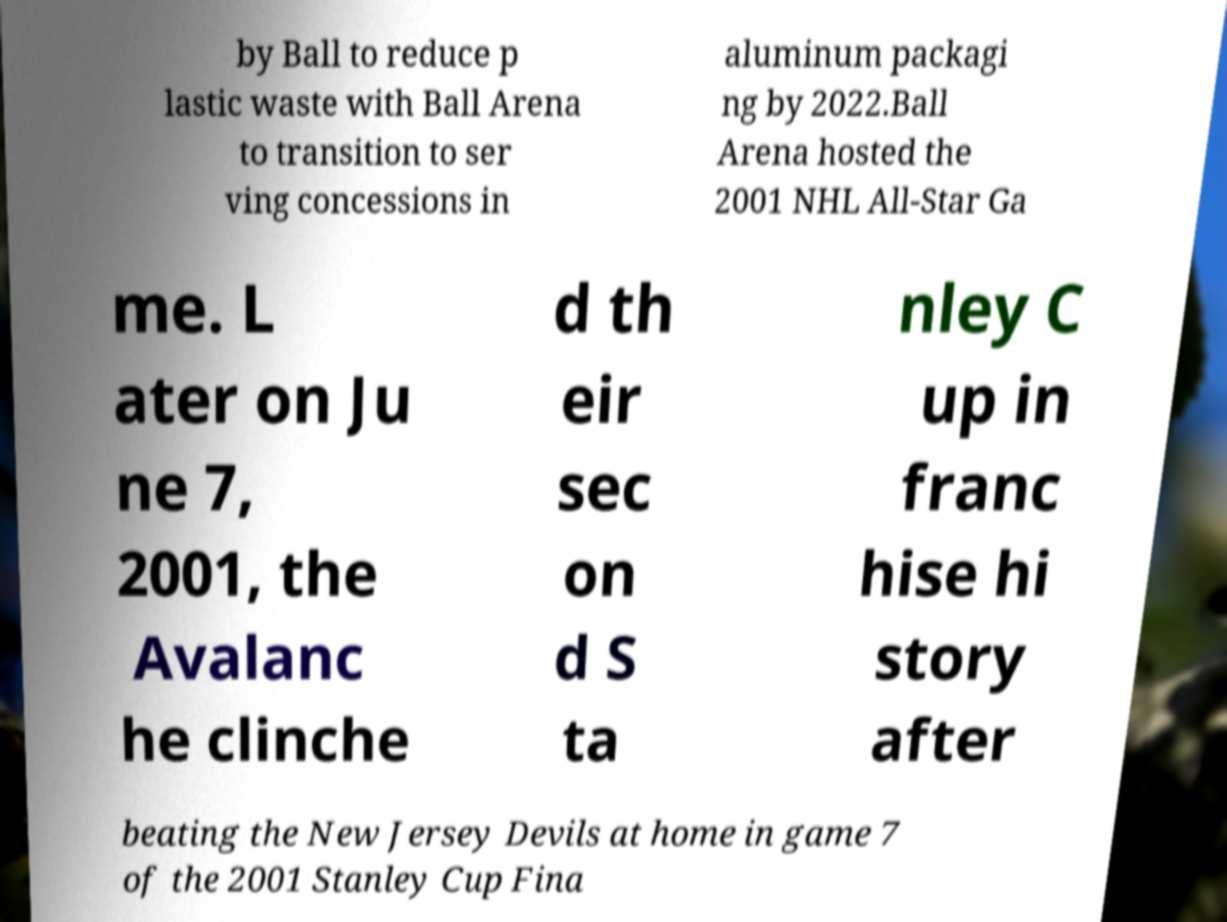Please read and relay the text visible in this image. What does it say? by Ball to reduce p lastic waste with Ball Arena to transition to ser ving concessions in aluminum packagi ng by 2022.Ball Arena hosted the 2001 NHL All-Star Ga me. L ater on Ju ne 7, 2001, the Avalanc he clinche d th eir sec on d S ta nley C up in franc hise hi story after beating the New Jersey Devils at home in game 7 of the 2001 Stanley Cup Fina 